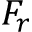Convert formula to latex. <formula><loc_0><loc_0><loc_500><loc_500>F _ { r }</formula> 